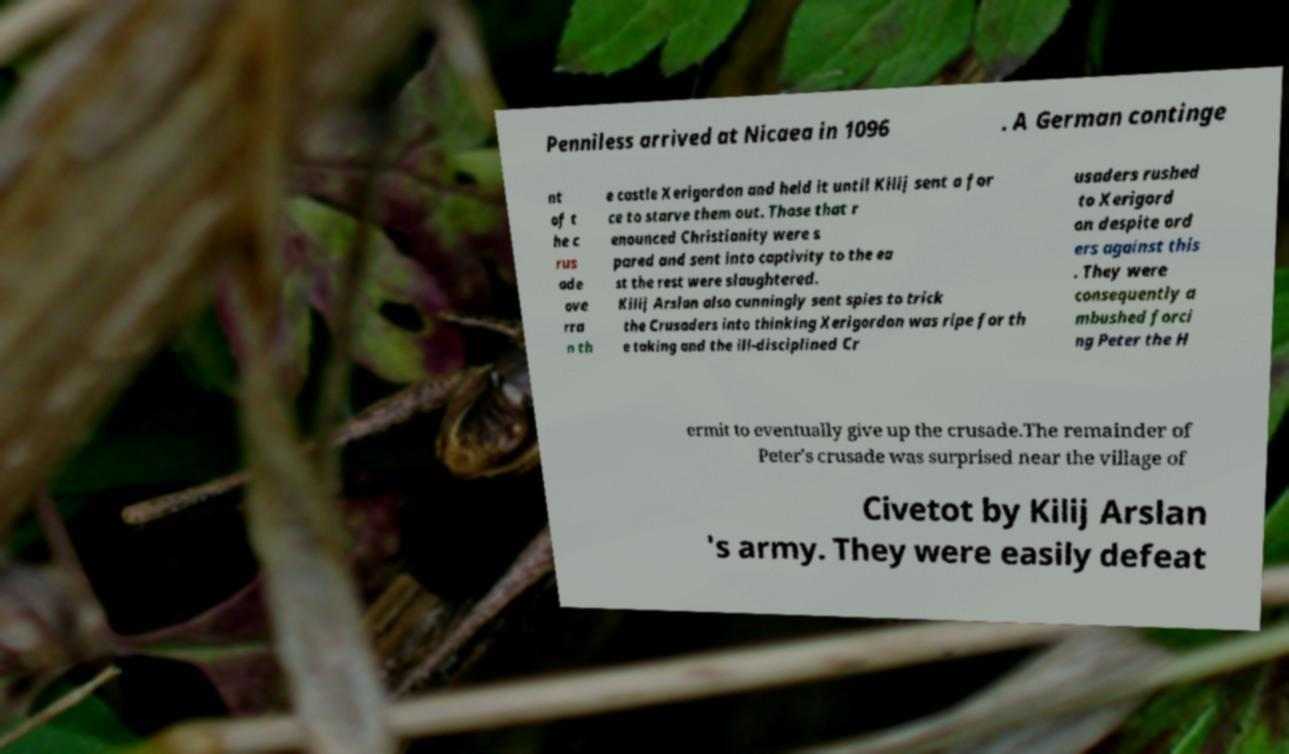There's text embedded in this image that I need extracted. Can you transcribe it verbatim? Penniless arrived at Nicaea in 1096 . A German continge nt of t he c rus ade ove rra n th e castle Xerigordon and held it until Kilij sent a for ce to starve them out. Those that r enounced Christianity were s pared and sent into captivity to the ea st the rest were slaughtered. Kilij Arslan also cunningly sent spies to trick the Crusaders into thinking Xerigordon was ripe for th e taking and the ill-disciplined Cr usaders rushed to Xerigord on despite ord ers against this . They were consequently a mbushed forci ng Peter the H ermit to eventually give up the crusade.The remainder of Peter's crusade was surprised near the village of Civetot by Kilij Arslan 's army. They were easily defeat 